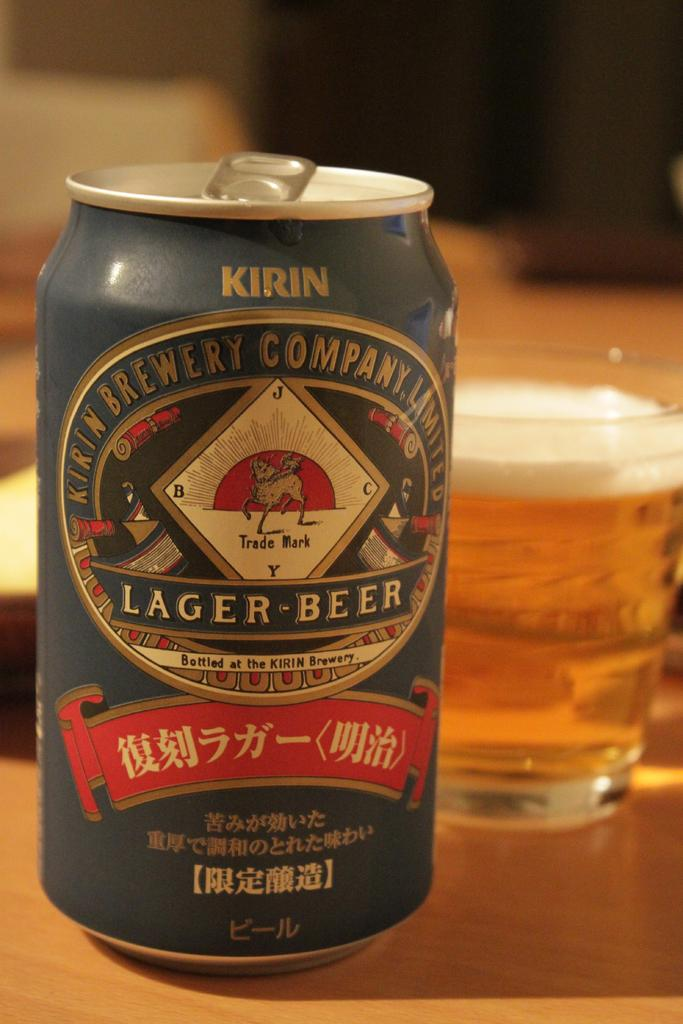Provide a one-sentence caption for the provided image. Can of Kirin Lager-Beer from the Kirin Brewery Company Limited. 